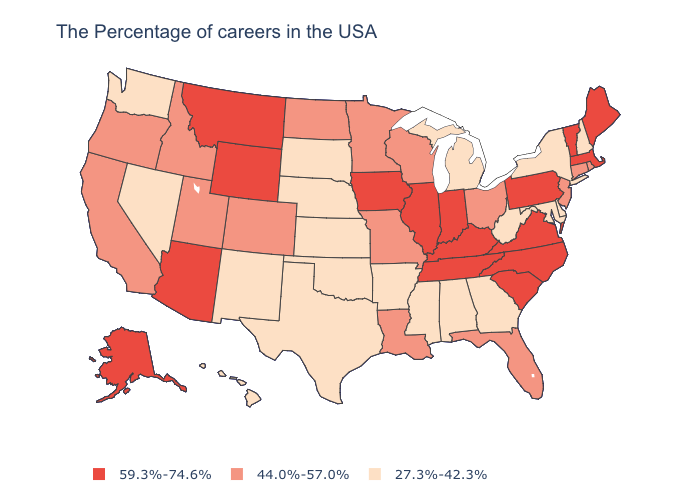What is the highest value in states that border Indiana?
Quick response, please. 59.3%-74.6%. Is the legend a continuous bar?
Answer briefly. No. What is the highest value in states that border South Carolina?
Give a very brief answer. 59.3%-74.6%. Does Tennessee have a higher value than Nevada?
Be succinct. Yes. Which states have the lowest value in the USA?
Short answer required. New Hampshire, New York, Delaware, Maryland, West Virginia, Georgia, Michigan, Alabama, Mississippi, Arkansas, Kansas, Nebraska, Oklahoma, Texas, South Dakota, New Mexico, Nevada, Washington, Hawaii. Does Nebraska have the lowest value in the MidWest?
Write a very short answer. Yes. Does the first symbol in the legend represent the smallest category?
Quick response, please. No. Among the states that border Ohio , does Indiana have the highest value?
Quick response, please. Yes. Does the first symbol in the legend represent the smallest category?
Short answer required. No. What is the lowest value in the USA?
Answer briefly. 27.3%-42.3%. Does Virginia have the lowest value in the USA?
Be succinct. No. What is the lowest value in states that border Idaho?
Write a very short answer. 27.3%-42.3%. What is the value of Mississippi?
Quick response, please. 27.3%-42.3%. What is the lowest value in the USA?
Short answer required. 27.3%-42.3%. What is the value of Illinois?
Answer briefly. 59.3%-74.6%. 